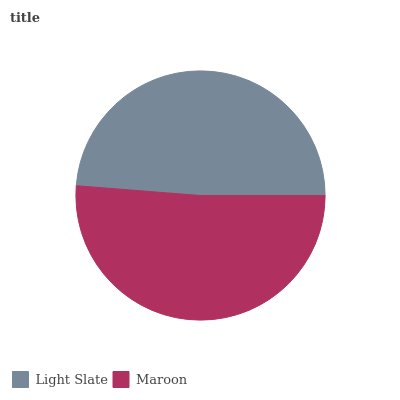Is Light Slate the minimum?
Answer yes or no. Yes. Is Maroon the maximum?
Answer yes or no. Yes. Is Maroon the minimum?
Answer yes or no. No. Is Maroon greater than Light Slate?
Answer yes or no. Yes. Is Light Slate less than Maroon?
Answer yes or no. Yes. Is Light Slate greater than Maroon?
Answer yes or no. No. Is Maroon less than Light Slate?
Answer yes or no. No. Is Maroon the high median?
Answer yes or no. Yes. Is Light Slate the low median?
Answer yes or no. Yes. Is Light Slate the high median?
Answer yes or no. No. Is Maroon the low median?
Answer yes or no. No. 